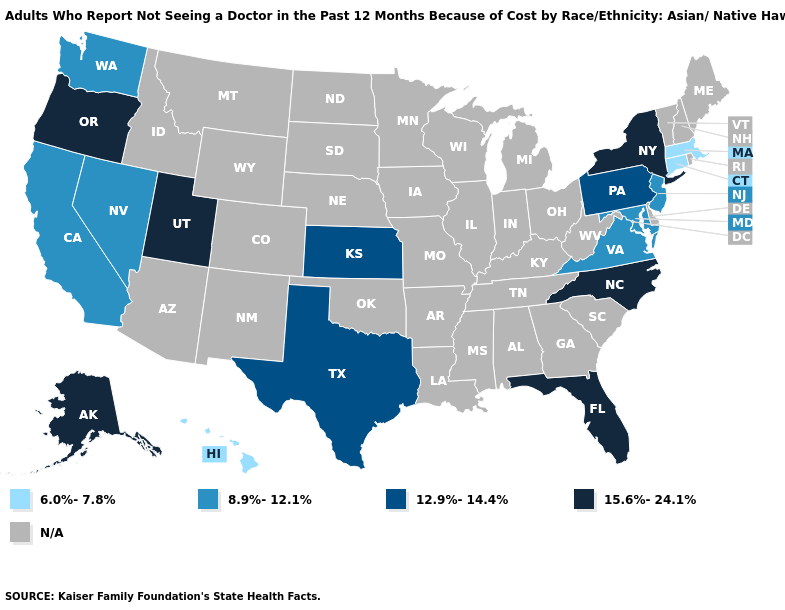Is the legend a continuous bar?
Give a very brief answer. No. What is the value of Hawaii?
Quick response, please. 6.0%-7.8%. Does Virginia have the highest value in the South?
Give a very brief answer. No. What is the lowest value in states that border Virginia?
Concise answer only. 8.9%-12.1%. What is the value of North Dakota?
Quick response, please. N/A. Name the states that have a value in the range 12.9%-14.4%?
Answer briefly. Kansas, Pennsylvania, Texas. What is the value of Tennessee?
Quick response, please. N/A. What is the value of New York?
Be succinct. 15.6%-24.1%. Does the first symbol in the legend represent the smallest category?
Answer briefly. Yes. Name the states that have a value in the range N/A?
Give a very brief answer. Alabama, Arizona, Arkansas, Colorado, Delaware, Georgia, Idaho, Illinois, Indiana, Iowa, Kentucky, Louisiana, Maine, Michigan, Minnesota, Mississippi, Missouri, Montana, Nebraska, New Hampshire, New Mexico, North Dakota, Ohio, Oklahoma, Rhode Island, South Carolina, South Dakota, Tennessee, Vermont, West Virginia, Wisconsin, Wyoming. What is the lowest value in states that border Nevada?
Be succinct. 8.9%-12.1%. What is the value of Rhode Island?
Be succinct. N/A. 